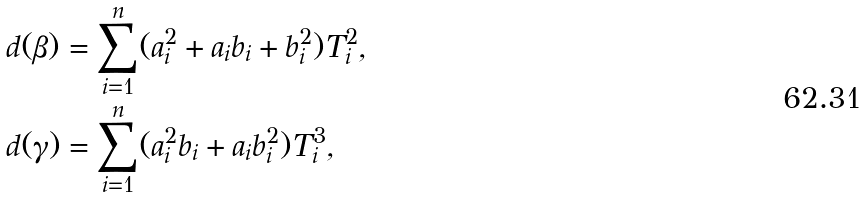<formula> <loc_0><loc_0><loc_500><loc_500>d ( \beta ) & = \sum _ { i = 1 } ^ { n } ( a _ { i } ^ { 2 } + a _ { i } b _ { i } + b _ { i } ^ { 2 } ) T _ { i } ^ { 2 } , \\ d ( \gamma ) & = \sum _ { i = 1 } ^ { n } ( a _ { i } ^ { 2 } b _ { i } + a _ { i } b _ { i } ^ { 2 } ) T _ { i } ^ { 3 } ,</formula> 